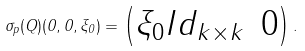Convert formula to latex. <formula><loc_0><loc_0><loc_500><loc_500>\sigma _ { p } ( Q ) ( 0 , 0 , \xi _ { 0 } ) = \begin{pmatrix} \xi _ { 0 } I d _ { k \times k } & 0 \end{pmatrix} .</formula> 